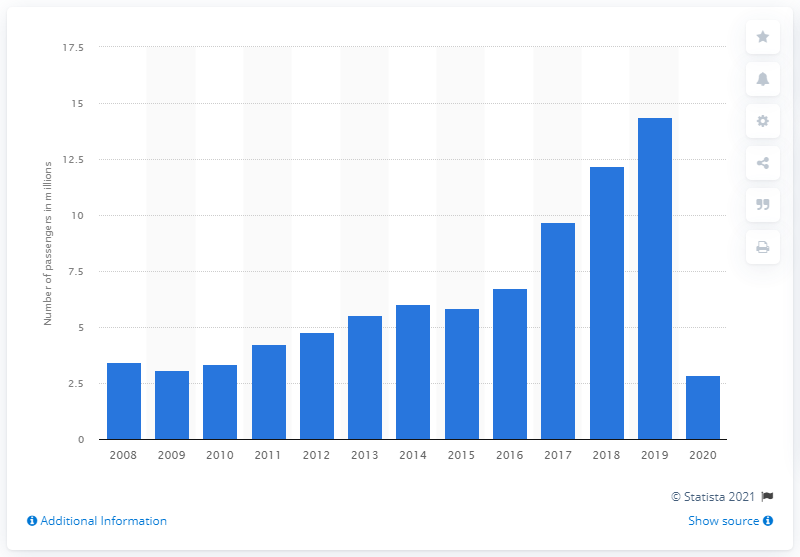Specify some key components in this picture. In 2020, Jet2.com carried a total of 2,850 passengers. Jet2.Com carried a total of 14,390 passengers in 2019. 